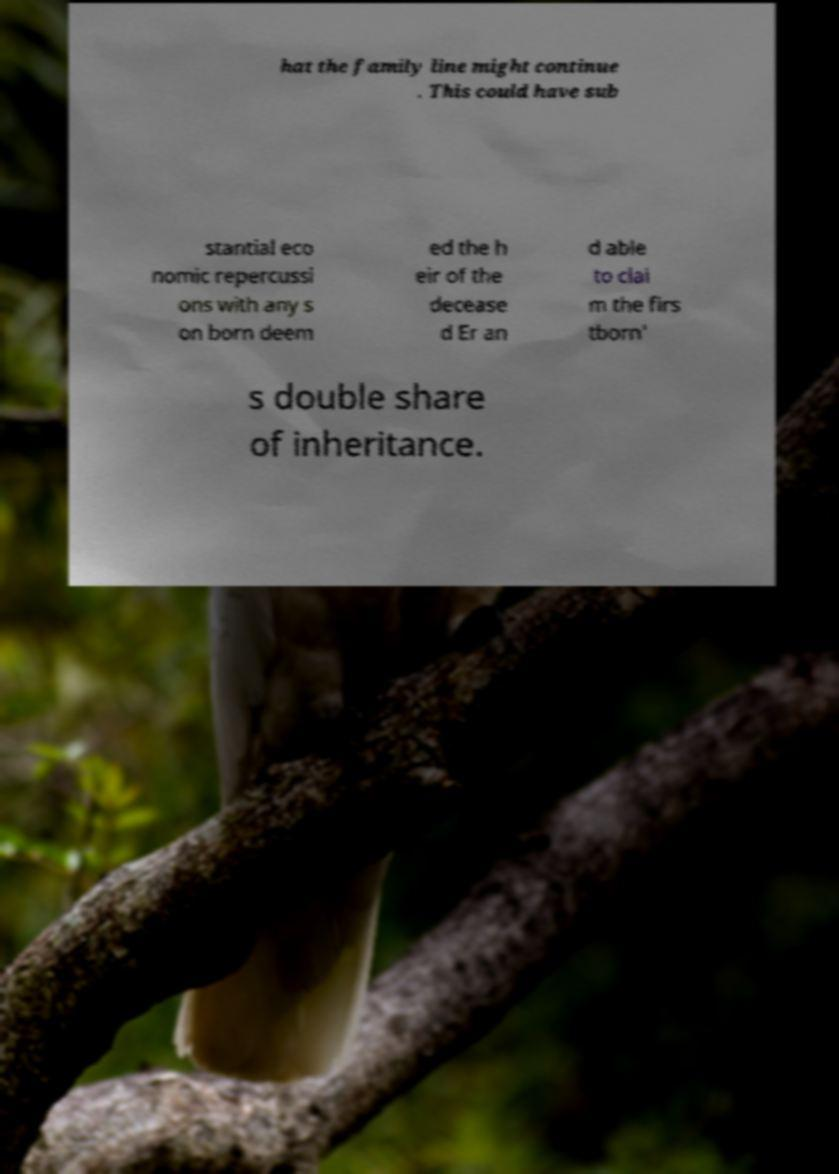For documentation purposes, I need the text within this image transcribed. Could you provide that? hat the family line might continue . This could have sub stantial eco nomic repercussi ons with any s on born deem ed the h eir of the decease d Er an d able to clai m the firs tborn' s double share of inheritance. 